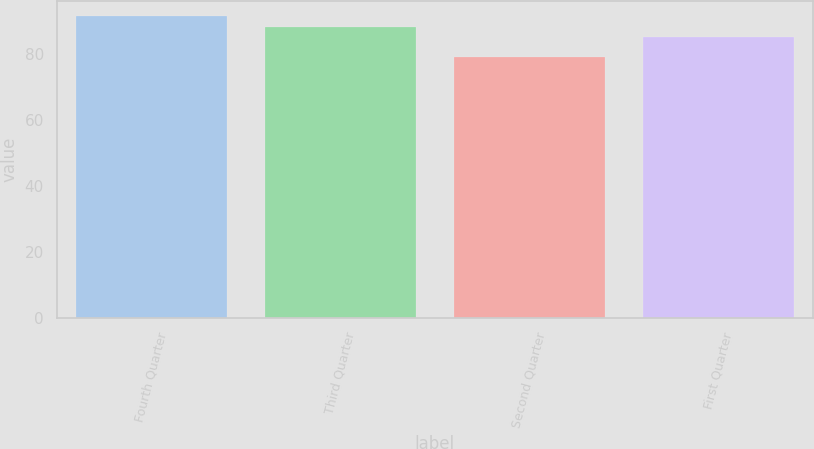Convert chart to OTSL. <chart><loc_0><loc_0><loc_500><loc_500><bar_chart><fcel>Fourth Quarter<fcel>Third Quarter<fcel>Second Quarter<fcel>First Quarter<nl><fcel>91.5<fcel>88.11<fcel>79<fcel>85<nl></chart> 